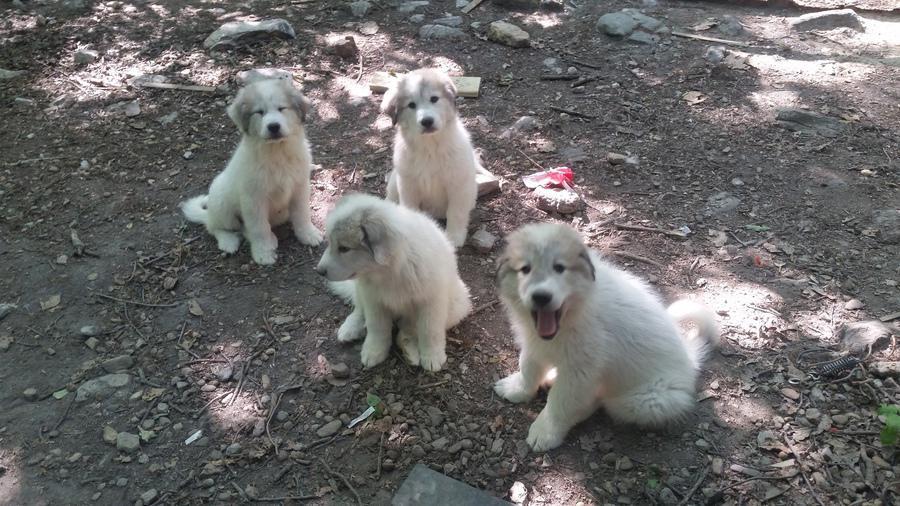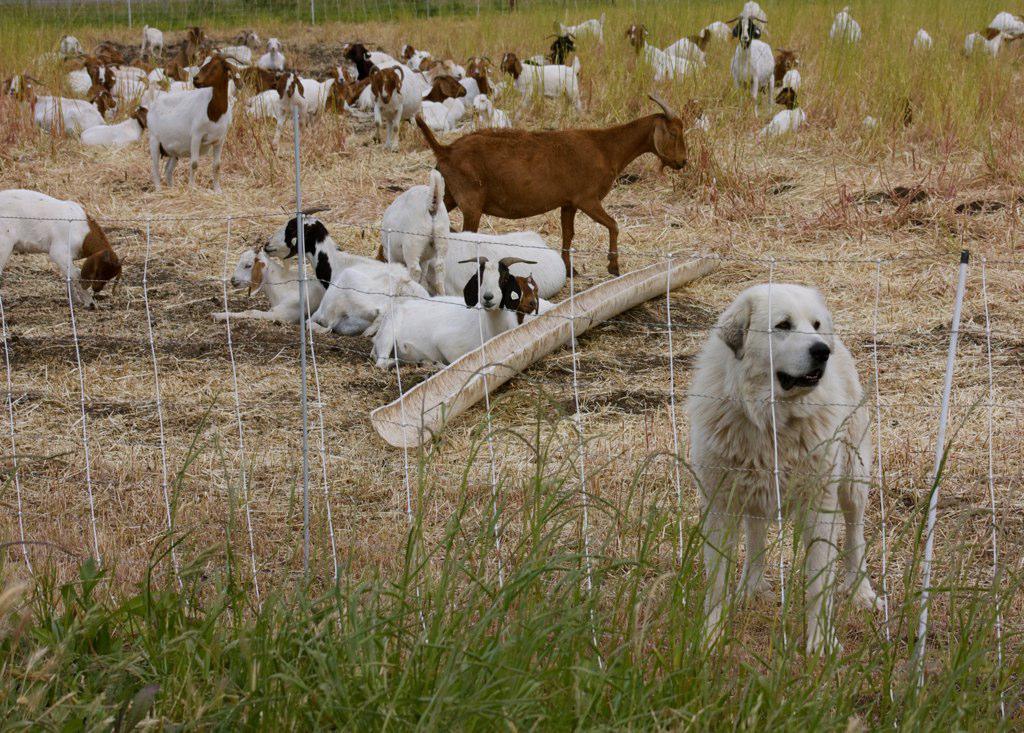The first image is the image on the left, the second image is the image on the right. For the images displayed, is the sentence "An image shows a white dog behind a wire fence with a herd of livestock." factually correct? Answer yes or no. Yes. 